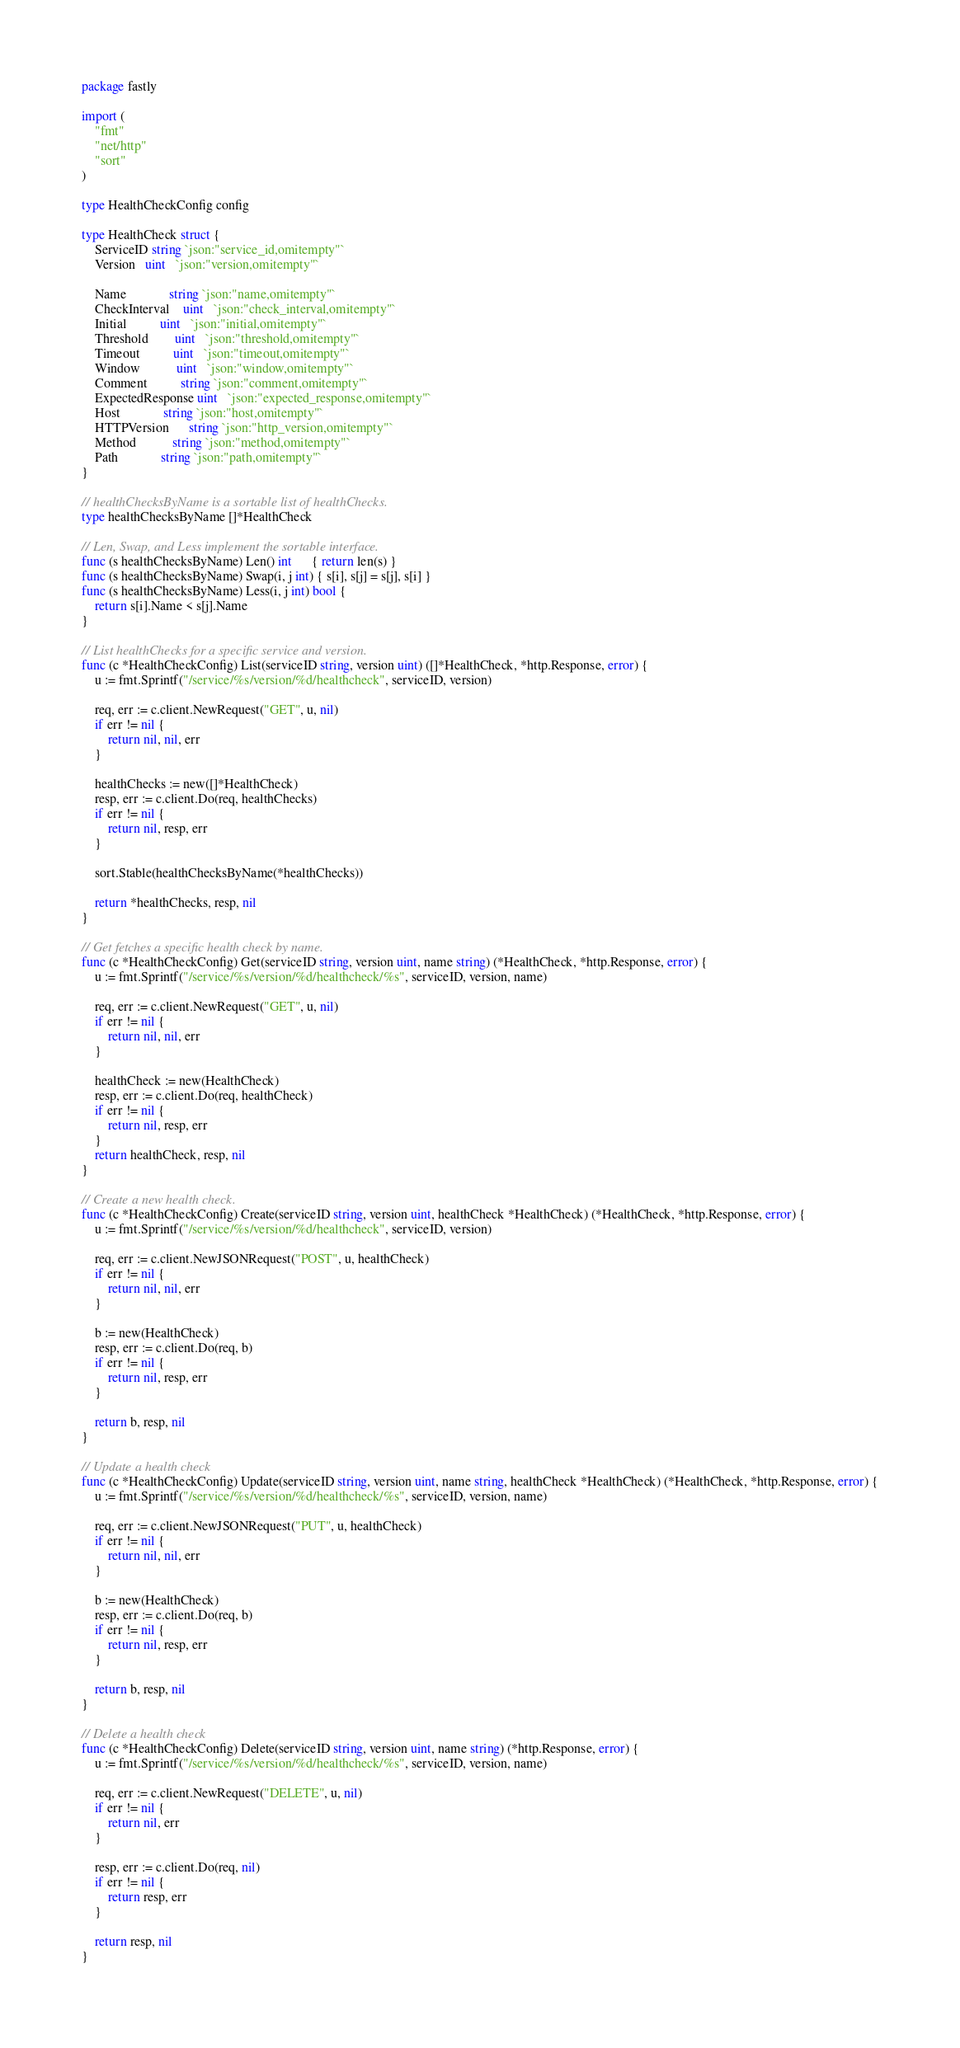Convert code to text. <code><loc_0><loc_0><loc_500><loc_500><_Go_>package fastly

import (
	"fmt"
	"net/http"
	"sort"
)

type HealthCheckConfig config

type HealthCheck struct {
	ServiceID string `json:"service_id,omitempty"`
	Version   uint   `json:"version,omitempty"`

	Name             string `json:"name,omitempty"`
	CheckInterval    uint   `json:"check_interval,omitempty"`
	Initial          uint   `json:"initial,omitempty"`
	Threshold        uint   `json:"threshold,omitempty"`
	Timeout          uint   `json:"timeout,omitempty"`
	Window           uint   `json:"window,omitempty"`
	Comment          string `json:"comment,omitempty"`
	ExpectedResponse uint   `json:"expected_response,omitempty"`
	Host             string `json:"host,omitempty"`
	HTTPVersion      string `json:"http_version,omitempty"`
	Method           string `json:"method,omitempty"`
	Path             string `json:"path,omitempty"`
}

// healthChecksByName is a sortable list of healthChecks.
type healthChecksByName []*HealthCheck

// Len, Swap, and Less implement the sortable interface.
func (s healthChecksByName) Len() int      { return len(s) }
func (s healthChecksByName) Swap(i, j int) { s[i], s[j] = s[j], s[i] }
func (s healthChecksByName) Less(i, j int) bool {
	return s[i].Name < s[j].Name
}

// List healthChecks for a specific service and version.
func (c *HealthCheckConfig) List(serviceID string, version uint) ([]*HealthCheck, *http.Response, error) {
	u := fmt.Sprintf("/service/%s/version/%d/healthcheck", serviceID, version)

	req, err := c.client.NewRequest("GET", u, nil)
	if err != nil {
		return nil, nil, err
	}

	healthChecks := new([]*HealthCheck)
	resp, err := c.client.Do(req, healthChecks)
	if err != nil {
		return nil, resp, err
	}

	sort.Stable(healthChecksByName(*healthChecks))

	return *healthChecks, resp, nil
}

// Get fetches a specific health check by name.
func (c *HealthCheckConfig) Get(serviceID string, version uint, name string) (*HealthCheck, *http.Response, error) {
	u := fmt.Sprintf("/service/%s/version/%d/healthcheck/%s", serviceID, version, name)

	req, err := c.client.NewRequest("GET", u, nil)
	if err != nil {
		return nil, nil, err
	}

	healthCheck := new(HealthCheck)
	resp, err := c.client.Do(req, healthCheck)
	if err != nil {
		return nil, resp, err
	}
	return healthCheck, resp, nil
}

// Create a new health check.
func (c *HealthCheckConfig) Create(serviceID string, version uint, healthCheck *HealthCheck) (*HealthCheck, *http.Response, error) {
	u := fmt.Sprintf("/service/%s/version/%d/healthcheck", serviceID, version)

	req, err := c.client.NewJSONRequest("POST", u, healthCheck)
	if err != nil {
		return nil, nil, err
	}

	b := new(HealthCheck)
	resp, err := c.client.Do(req, b)
	if err != nil {
		return nil, resp, err
	}

	return b, resp, nil
}

// Update a health check
func (c *HealthCheckConfig) Update(serviceID string, version uint, name string, healthCheck *HealthCheck) (*HealthCheck, *http.Response, error) {
	u := fmt.Sprintf("/service/%s/version/%d/healthcheck/%s", serviceID, version, name)

	req, err := c.client.NewJSONRequest("PUT", u, healthCheck)
	if err != nil {
		return nil, nil, err
	}

	b := new(HealthCheck)
	resp, err := c.client.Do(req, b)
	if err != nil {
		return nil, resp, err
	}

	return b, resp, nil
}

// Delete a health check
func (c *HealthCheckConfig) Delete(serviceID string, version uint, name string) (*http.Response, error) {
	u := fmt.Sprintf("/service/%s/version/%d/healthcheck/%s", serviceID, version, name)

	req, err := c.client.NewRequest("DELETE", u, nil)
	if err != nil {
		return nil, err
	}

	resp, err := c.client.Do(req, nil)
	if err != nil {
		return resp, err
	}

	return resp, nil
}
</code> 